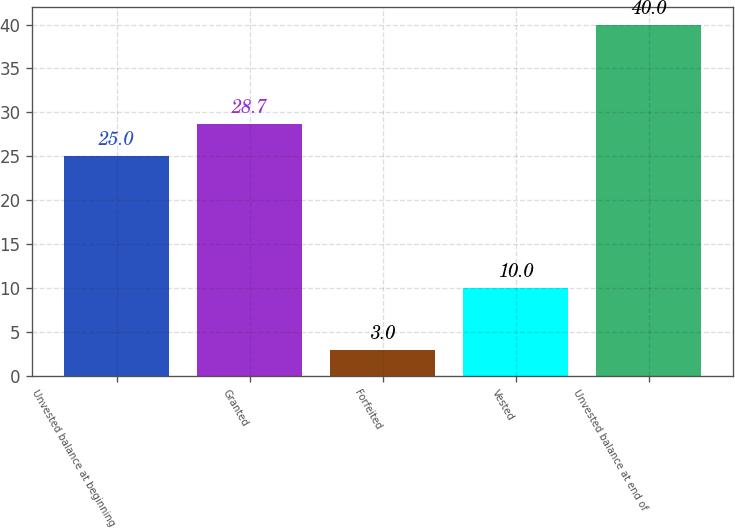Convert chart. <chart><loc_0><loc_0><loc_500><loc_500><bar_chart><fcel>Unvested balance at beginning<fcel>Granted<fcel>Forfeited<fcel>Vested<fcel>Unvested balance at end of<nl><fcel>25<fcel>28.7<fcel>3<fcel>10<fcel>40<nl></chart> 